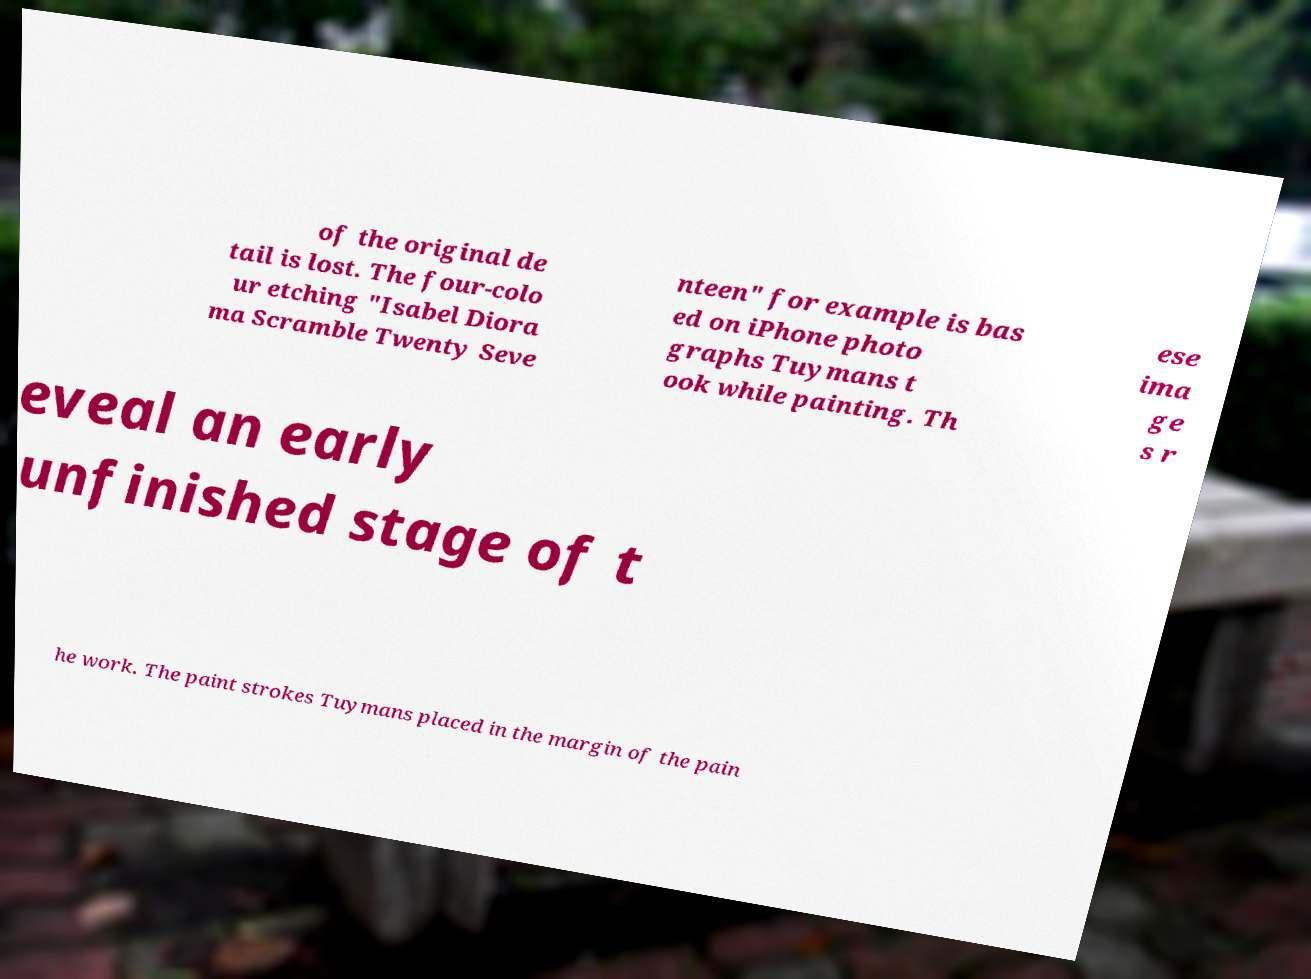I need the written content from this picture converted into text. Can you do that? of the original de tail is lost. The four-colo ur etching "Isabel Diora ma Scramble Twenty Seve nteen" for example is bas ed on iPhone photo graphs Tuymans t ook while painting. Th ese ima ge s r eveal an early unfinished stage of t he work. The paint strokes Tuymans placed in the margin of the pain 